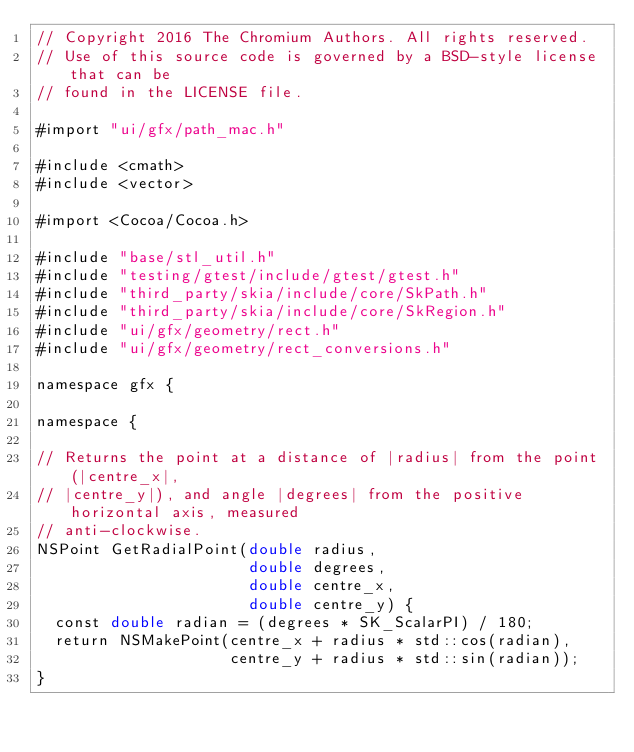Convert code to text. <code><loc_0><loc_0><loc_500><loc_500><_ObjectiveC_>// Copyright 2016 The Chromium Authors. All rights reserved.
// Use of this source code is governed by a BSD-style license that can be
// found in the LICENSE file.

#import "ui/gfx/path_mac.h"

#include <cmath>
#include <vector>

#import <Cocoa/Cocoa.h>

#include "base/stl_util.h"
#include "testing/gtest/include/gtest/gtest.h"
#include "third_party/skia/include/core/SkPath.h"
#include "third_party/skia/include/core/SkRegion.h"
#include "ui/gfx/geometry/rect.h"
#include "ui/gfx/geometry/rect_conversions.h"

namespace gfx {

namespace {

// Returns the point at a distance of |radius| from the point (|centre_x|,
// |centre_y|), and angle |degrees| from the positive horizontal axis, measured
// anti-clockwise.
NSPoint GetRadialPoint(double radius,
                       double degrees,
                       double centre_x,
                       double centre_y) {
  const double radian = (degrees * SK_ScalarPI) / 180;
  return NSMakePoint(centre_x + radius * std::cos(radian),
                     centre_y + radius * std::sin(radian));
}
</code> 